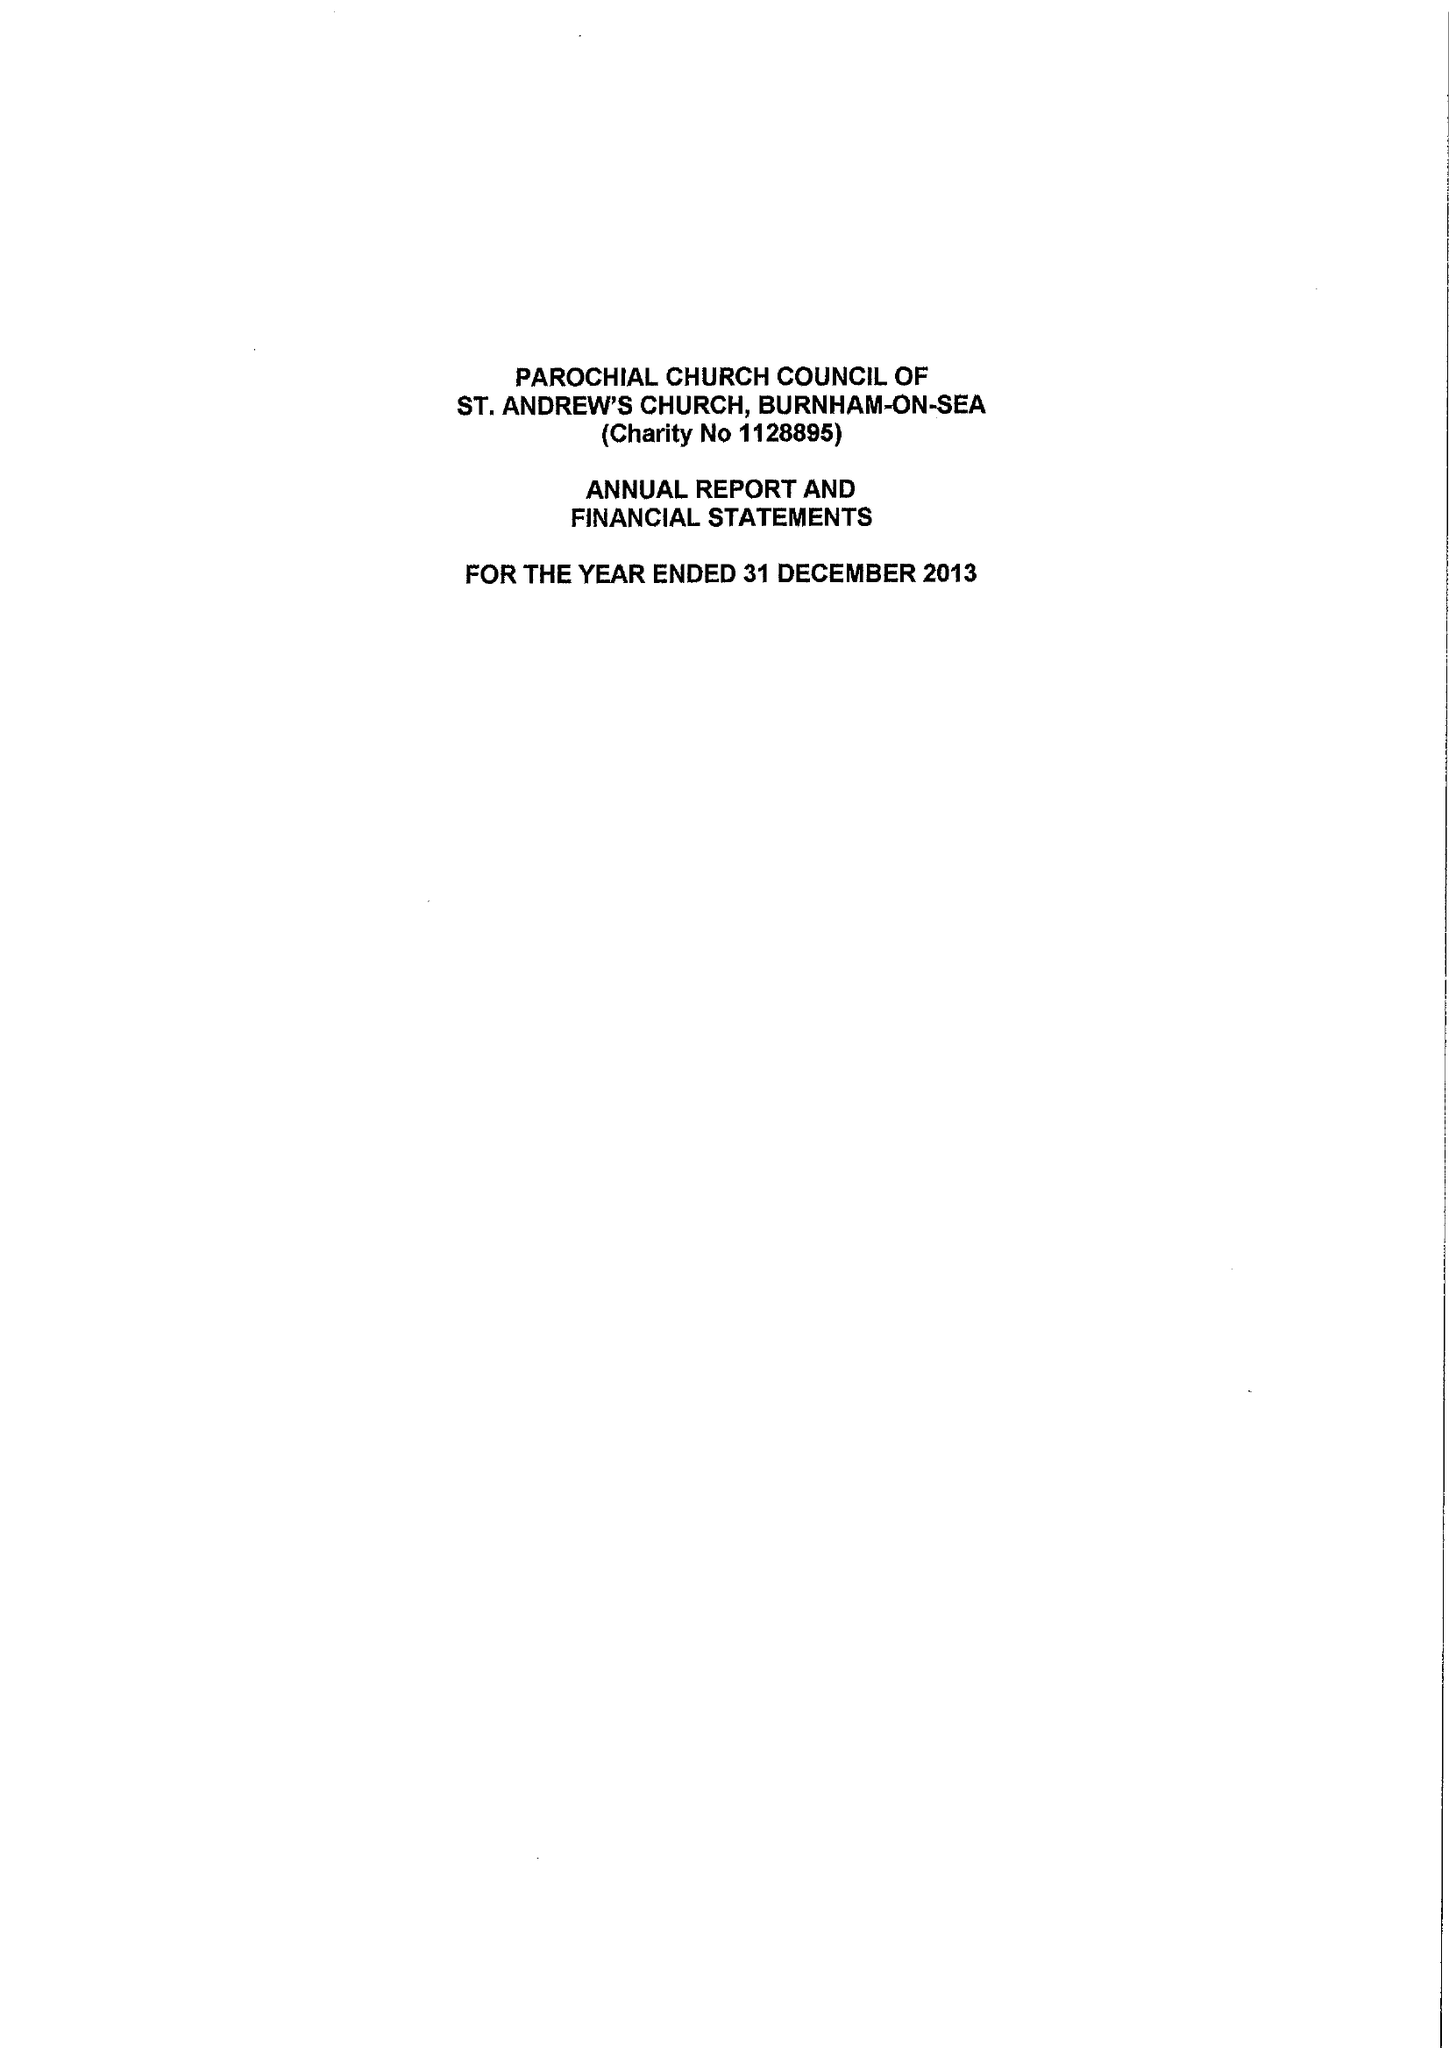What is the value for the charity_name?
Answer the question using a single word or phrase. The Parochial Church Council Of The Ecclesiastical Parish Of St Andrew, Burnham-On-Sea 